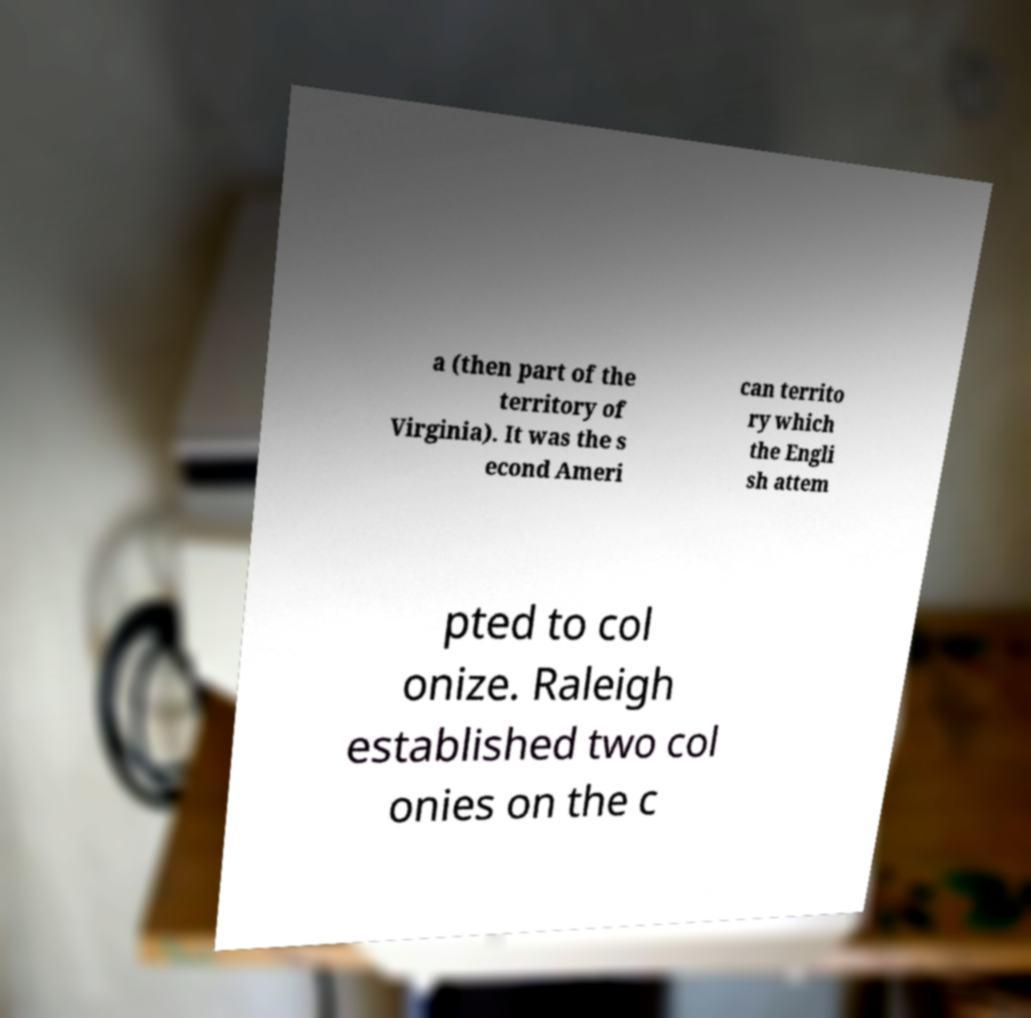What messages or text are displayed in this image? I need them in a readable, typed format. a (then part of the territory of Virginia). It was the s econd Ameri can territo ry which the Engli sh attem pted to col onize. Raleigh established two col onies on the c 